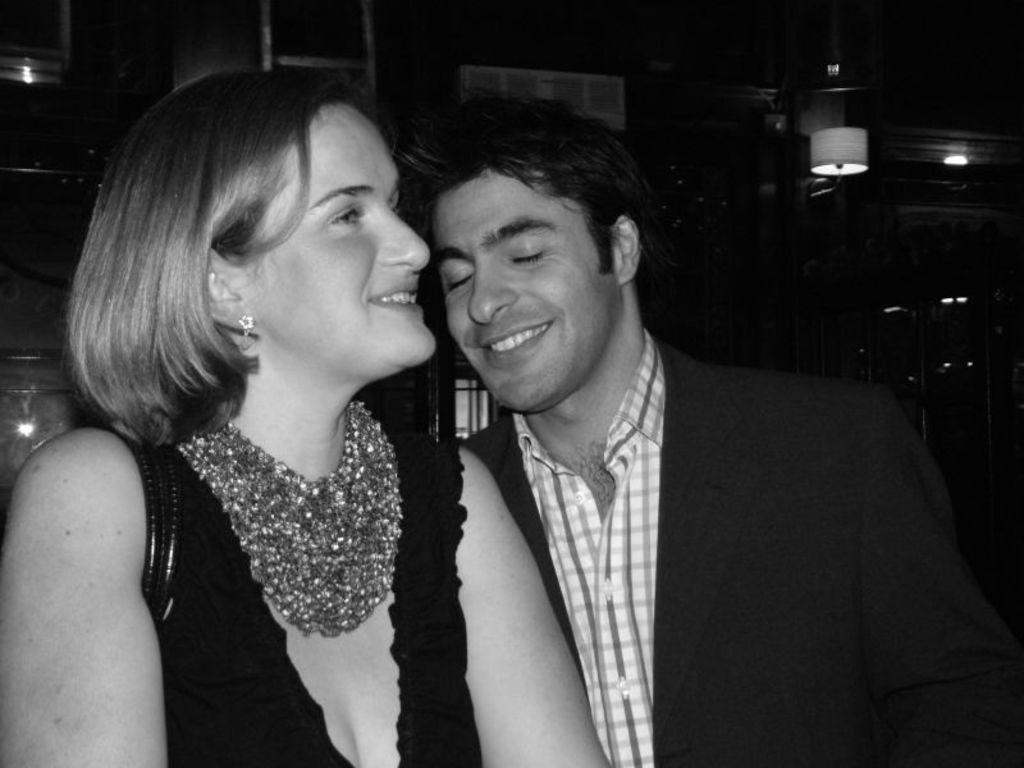What is the appearance of the girl in the image? There is a beautiful girl in the image. What expression does the girl have? The girl is smiling. What color is the top the girl is wearing? The girl is wearing a black color top. Who else is present in the image? There is a man in the image. What expression does the man have? The man is smiling. What type of clothing is the man wearing? The man is wearing a coat and a shirt. What color scheme is used in the image? The image is in black and white color. What verse can be heard being recited by the girl in the image? There is no verse being recited in the image, as it is a black and white photograph of a smiling girl and a man. Is there any indication of hate or animosity between the girl and the man in the image? No, both the girl and the man are smiling, which suggests a positive or friendly interaction between them. 